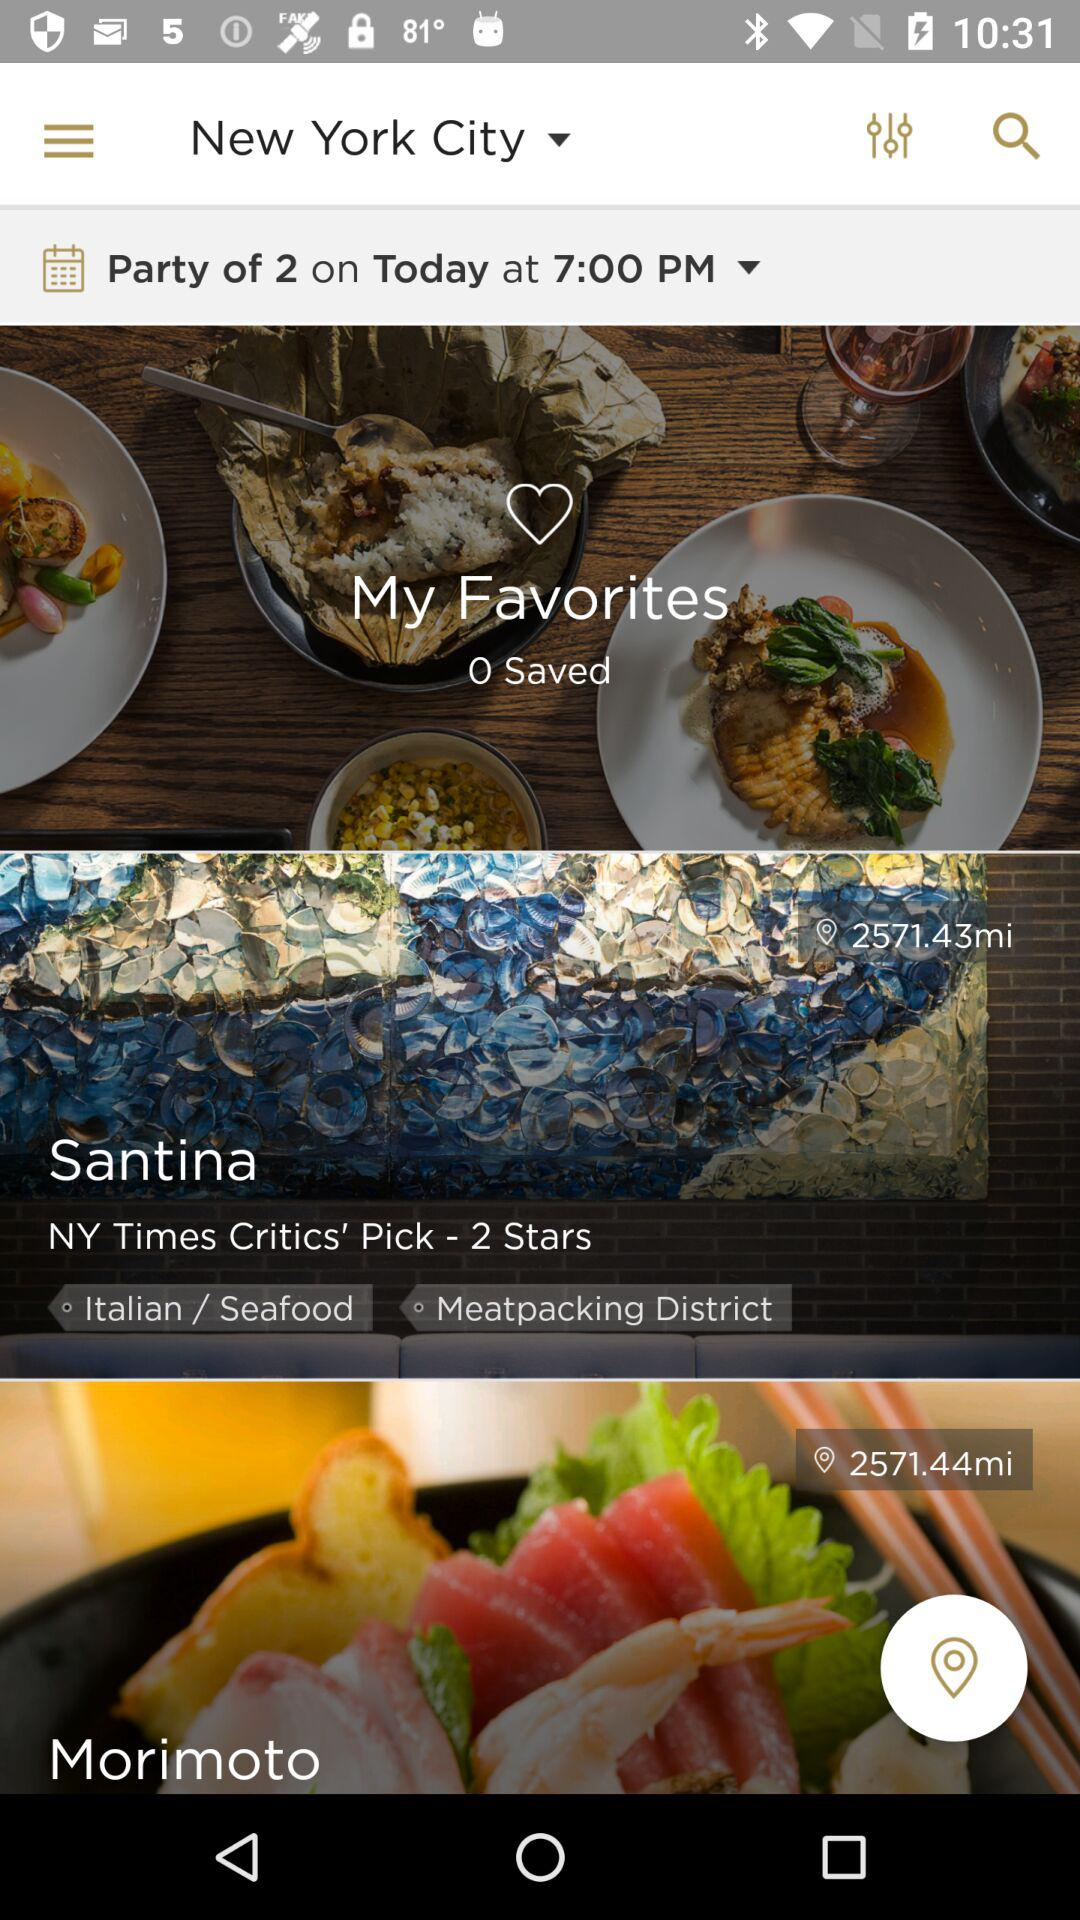What city is selected? The selected city is New York. 